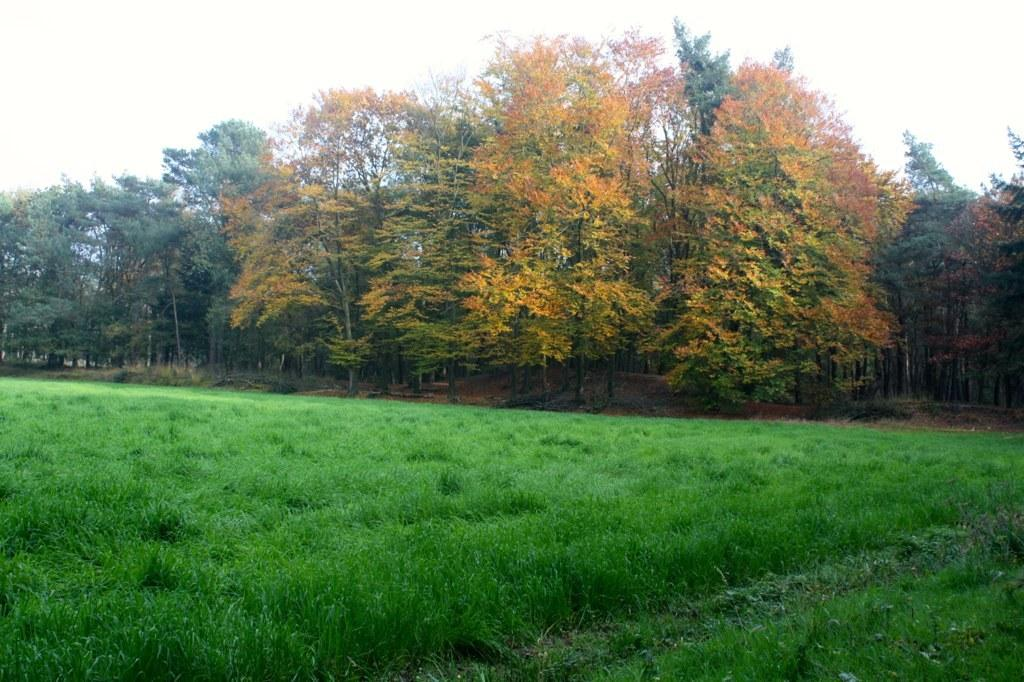What is there is a large grassy area in the image. What is its size? There is a big grass field in the image. What can be found beside the grass field? There are many trees beside the grass field. What type of business is being conducted in the grass field? There is no indication of any business activity in the grass field; it is simply a large grassy area with trees beside it. 